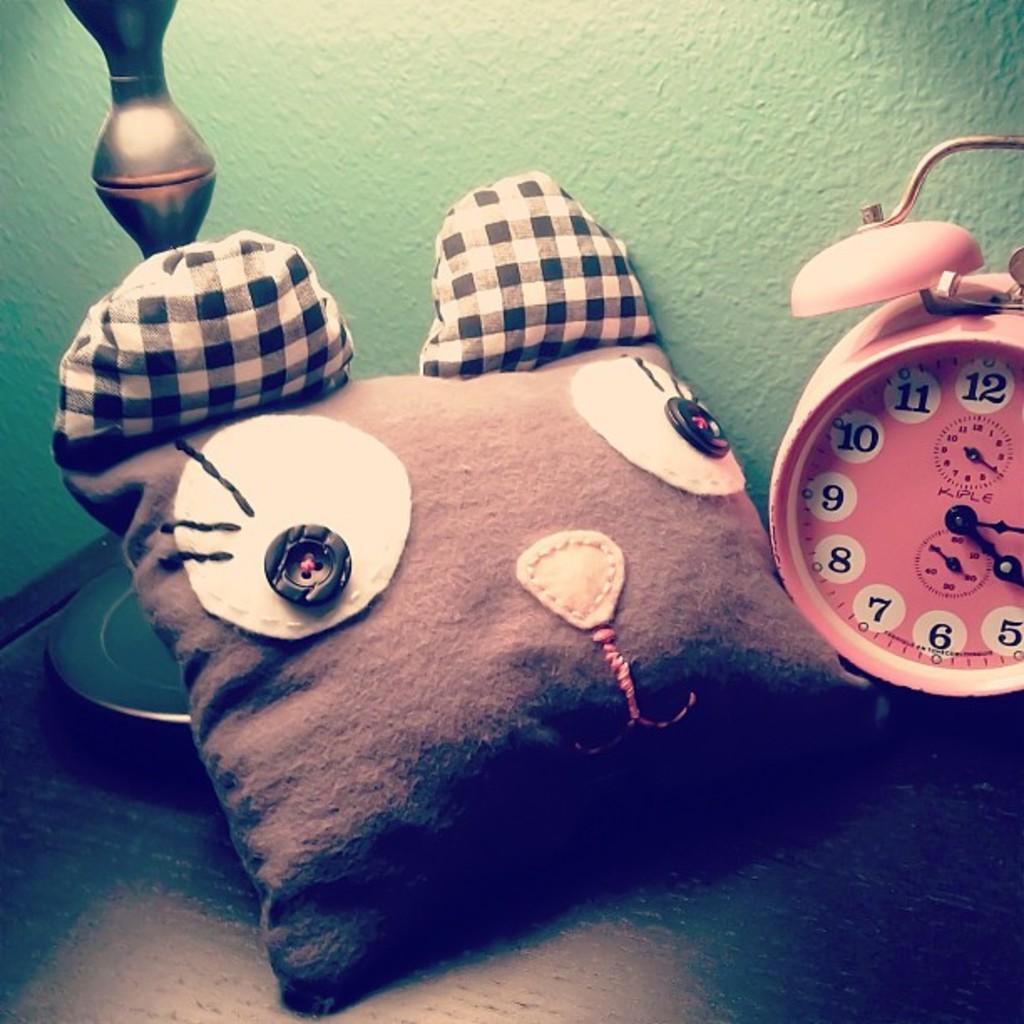<image>
Write a terse but informative summary of the picture. An old style Kiple clock sitting next to a stuffed animal and a lamp base. 